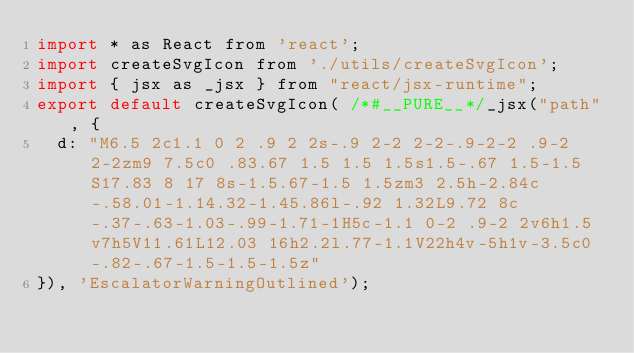Convert code to text. <code><loc_0><loc_0><loc_500><loc_500><_JavaScript_>import * as React from 'react';
import createSvgIcon from './utils/createSvgIcon';
import { jsx as _jsx } from "react/jsx-runtime";
export default createSvgIcon( /*#__PURE__*/_jsx("path", {
  d: "M6.5 2c1.1 0 2 .9 2 2s-.9 2-2 2-2-.9-2-2 .9-2 2-2zm9 7.5c0 .83.67 1.5 1.5 1.5s1.5-.67 1.5-1.5S17.83 8 17 8s-1.5.67-1.5 1.5zm3 2.5h-2.84c-.58.01-1.14.32-1.45.86l-.92 1.32L9.72 8c-.37-.63-1.03-.99-1.71-1H5c-1.1 0-2 .9-2 2v6h1.5v7h5V11.61L12.03 16h2.2l.77-1.1V22h4v-5h1v-3.5c0-.82-.67-1.5-1.5-1.5z"
}), 'EscalatorWarningOutlined');</code> 